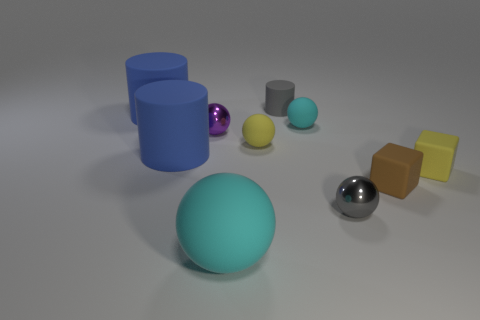Subtract all purple balls. How many balls are left? 4 Subtract all tiny yellow rubber spheres. How many spheres are left? 4 Subtract all blue balls. Subtract all purple cubes. How many balls are left? 5 Subtract all blocks. How many objects are left? 8 Add 1 small blocks. How many small blocks exist? 3 Subtract 1 blue cylinders. How many objects are left? 9 Subtract all shiny balls. Subtract all rubber blocks. How many objects are left? 6 Add 3 brown objects. How many brown objects are left? 4 